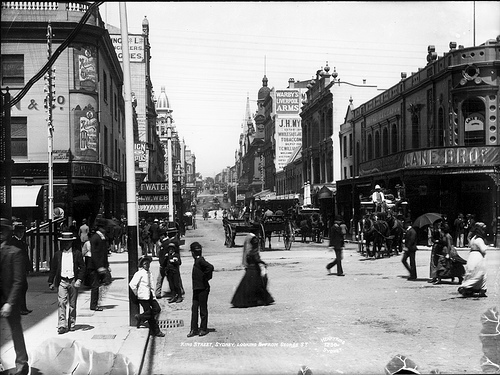Identify the text contained in this image. ARMS WATER LANE J.H.M N L 